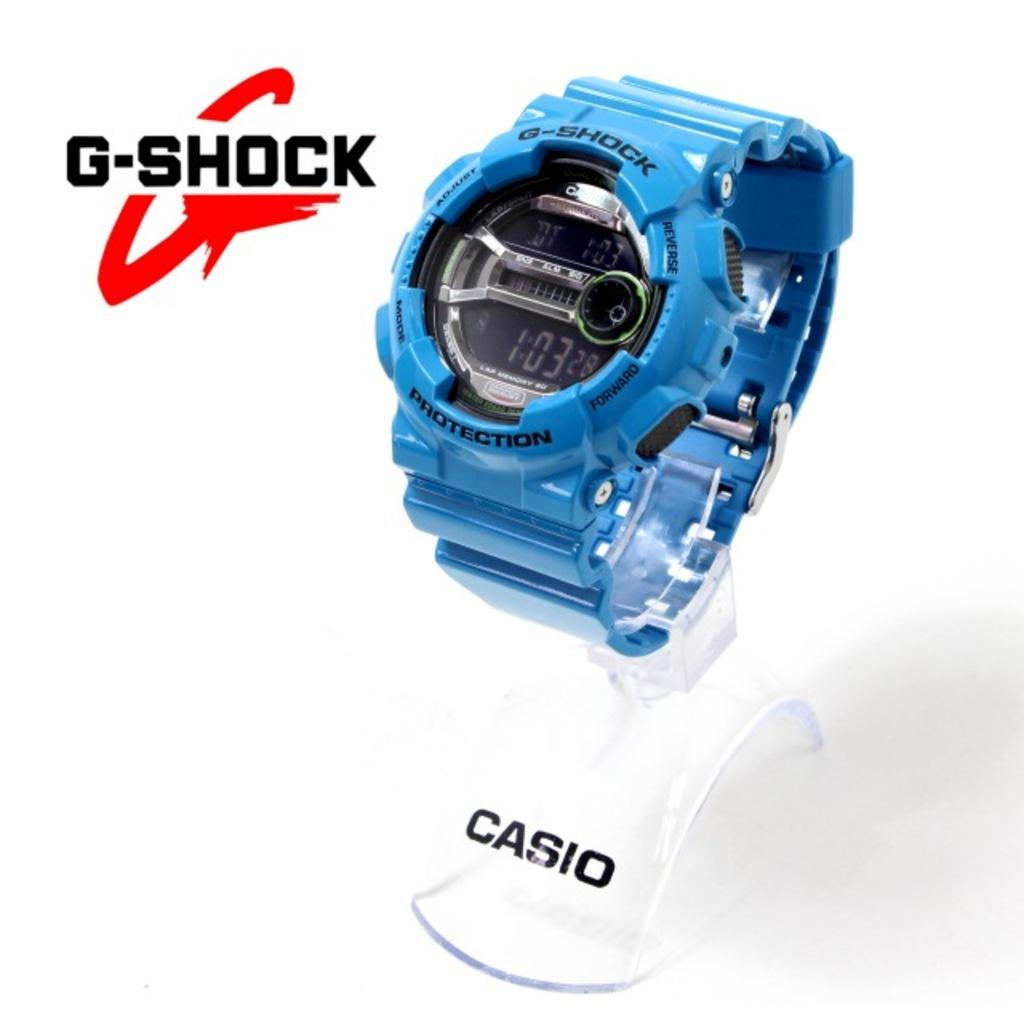<image>
Give a short and clear explanation of the subsequent image. A Casio watch with G-Shock protection is on display. 